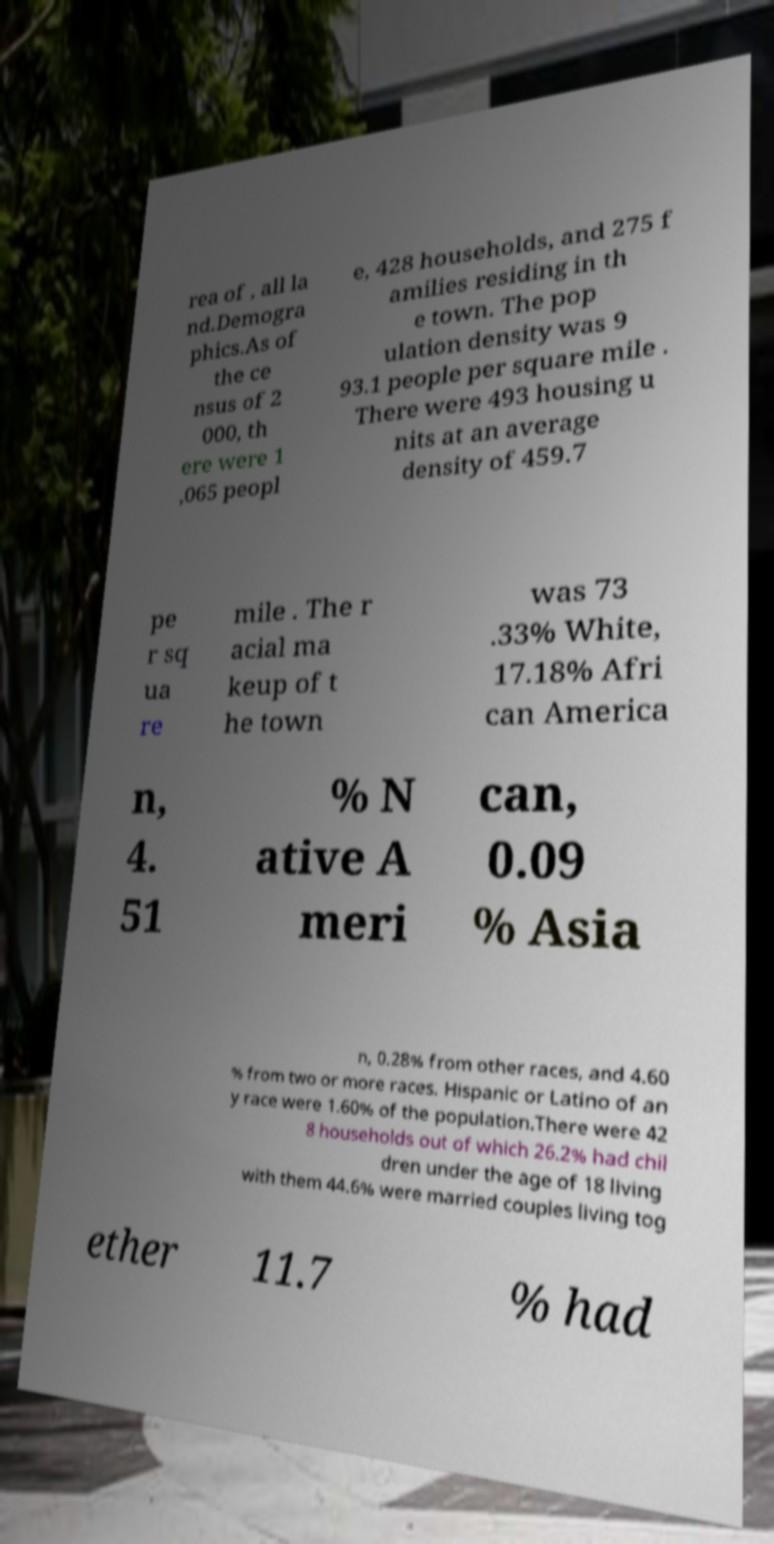For documentation purposes, I need the text within this image transcribed. Could you provide that? rea of , all la nd.Demogra phics.As of the ce nsus of 2 000, th ere were 1 ,065 peopl e, 428 households, and 275 f amilies residing in th e town. The pop ulation density was 9 93.1 people per square mile . There were 493 housing u nits at an average density of 459.7 pe r sq ua re mile . The r acial ma keup of t he town was 73 .33% White, 17.18% Afri can America n, 4. 51 % N ative A meri can, 0.09 % Asia n, 0.28% from other races, and 4.60 % from two or more races. Hispanic or Latino of an y race were 1.60% of the population.There were 42 8 households out of which 26.2% had chil dren under the age of 18 living with them 44.6% were married couples living tog ether 11.7 % had 